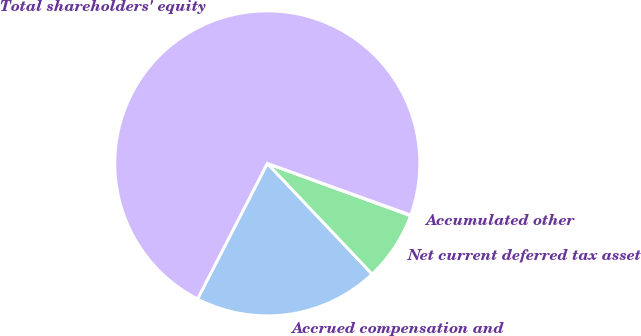Convert chart. <chart><loc_0><loc_0><loc_500><loc_500><pie_chart><fcel>Accrued compensation and<fcel>Net current deferred tax asset<fcel>Accumulated other<fcel>Total shareholders' equity<nl><fcel>19.63%<fcel>7.36%<fcel>0.07%<fcel>72.94%<nl></chart> 